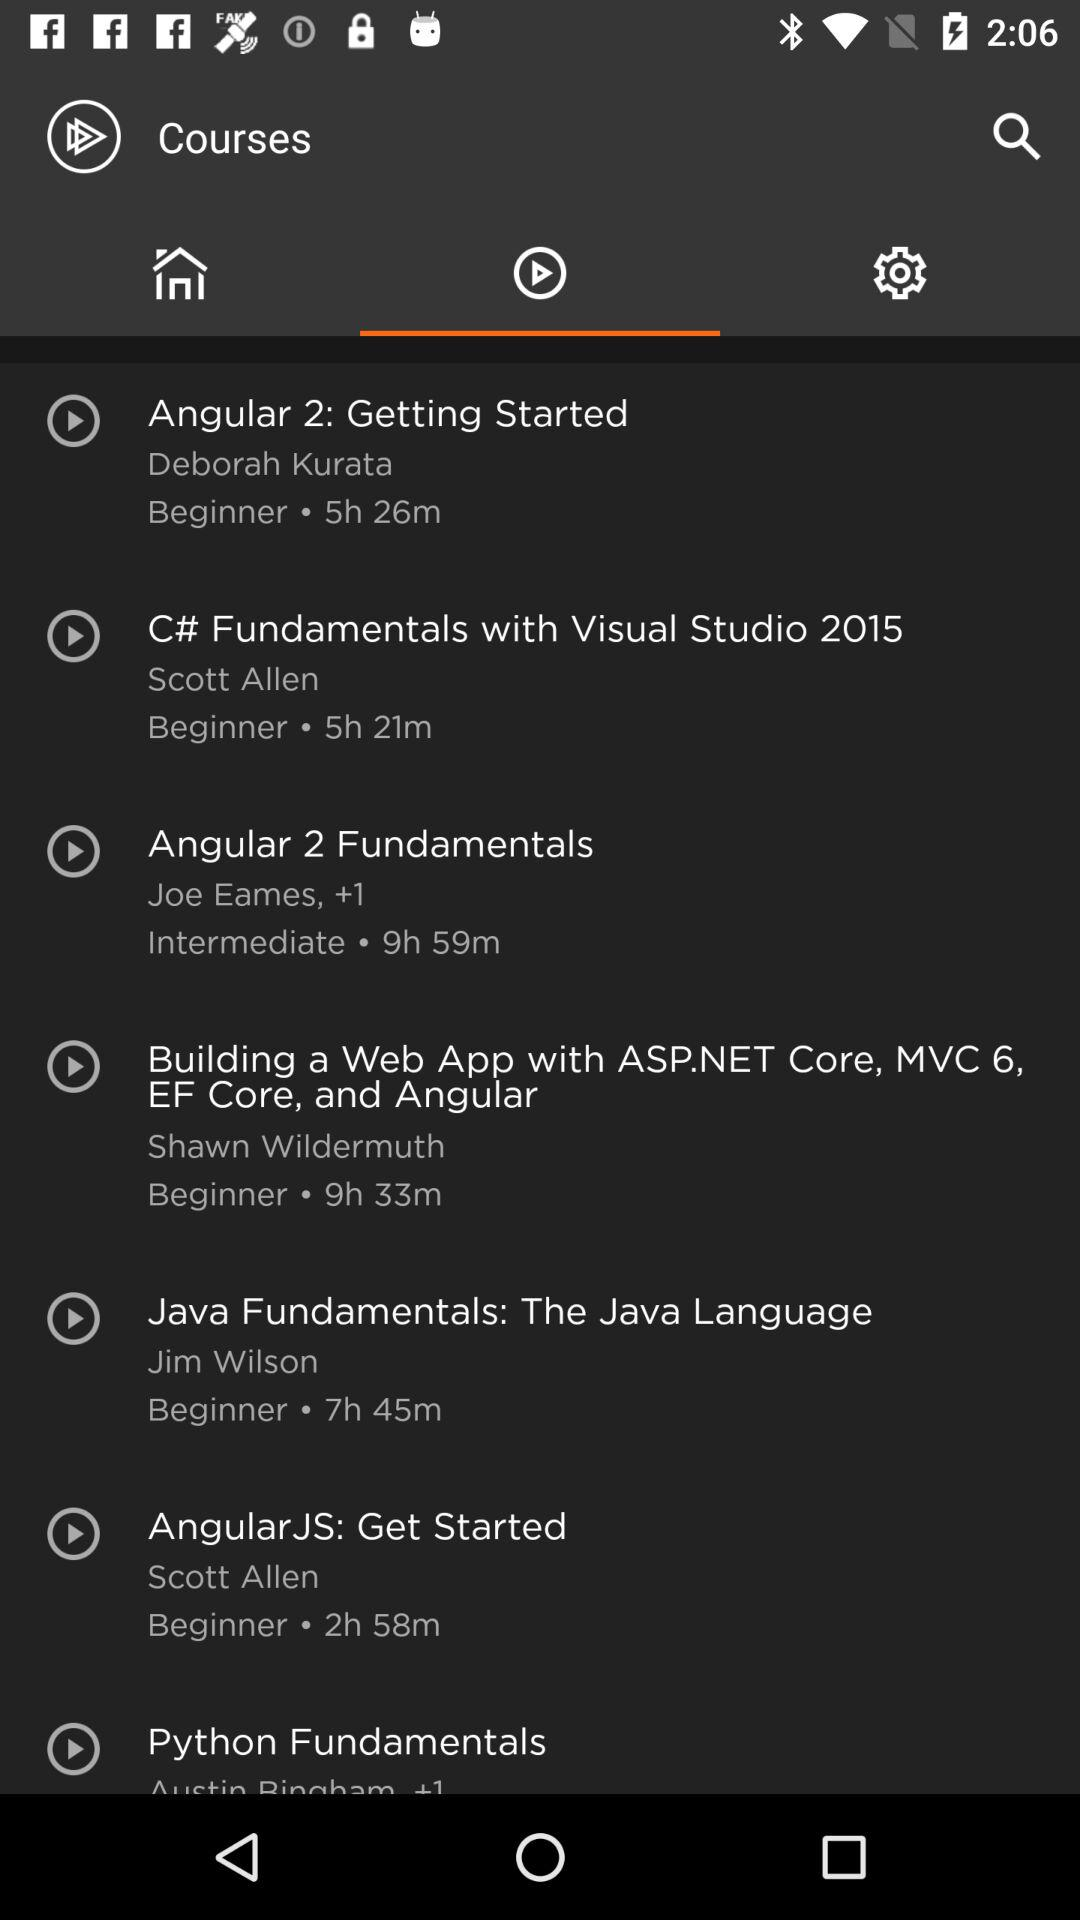What is the duration of Python fundamental?
When the provided information is insufficient, respond with <no answer>. <no answer> 